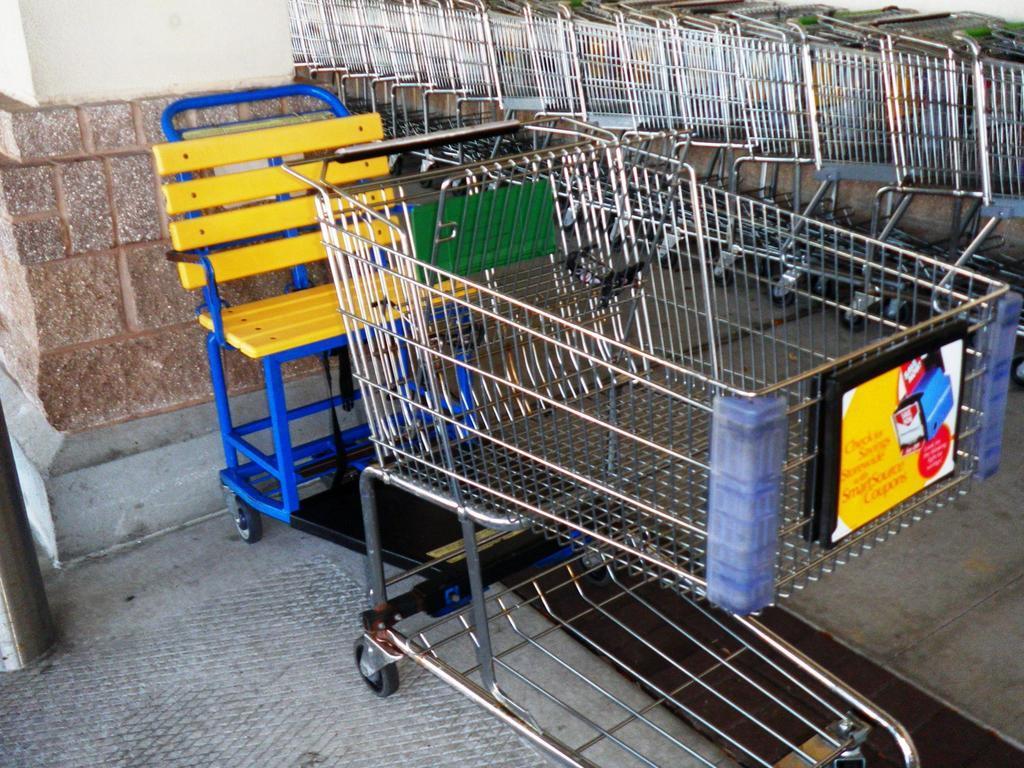Can you describe this image briefly? In this image in the foreground there is one trolley and chair and in the background there are group of trolleys, and on the left side there is wall. At the bottom there is floor. 